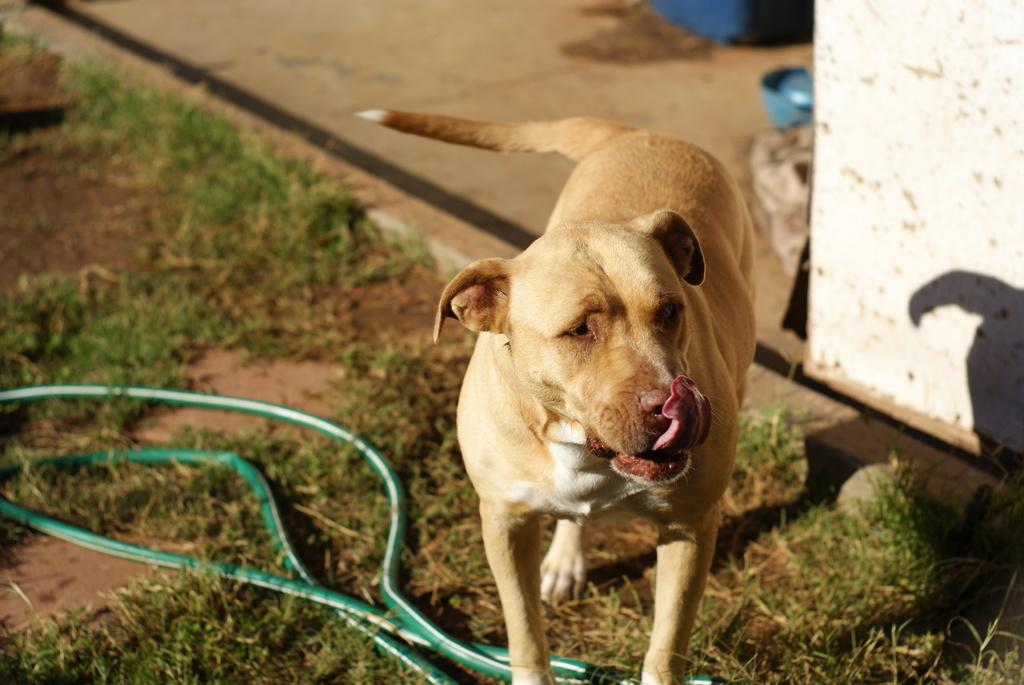What type of animal is in the image? There is a dog in the image. What is the dog's position in the image? The dog is standing on the land. What color is the dog? The dog is cream-colored. What can be seen on the ground in the image? There is a green color pipe on the ground. What is on the right side of the image? There is a wall on the right side of the image. What type of vest is the man wearing in the image? There is no man present in the image, only a dog. 